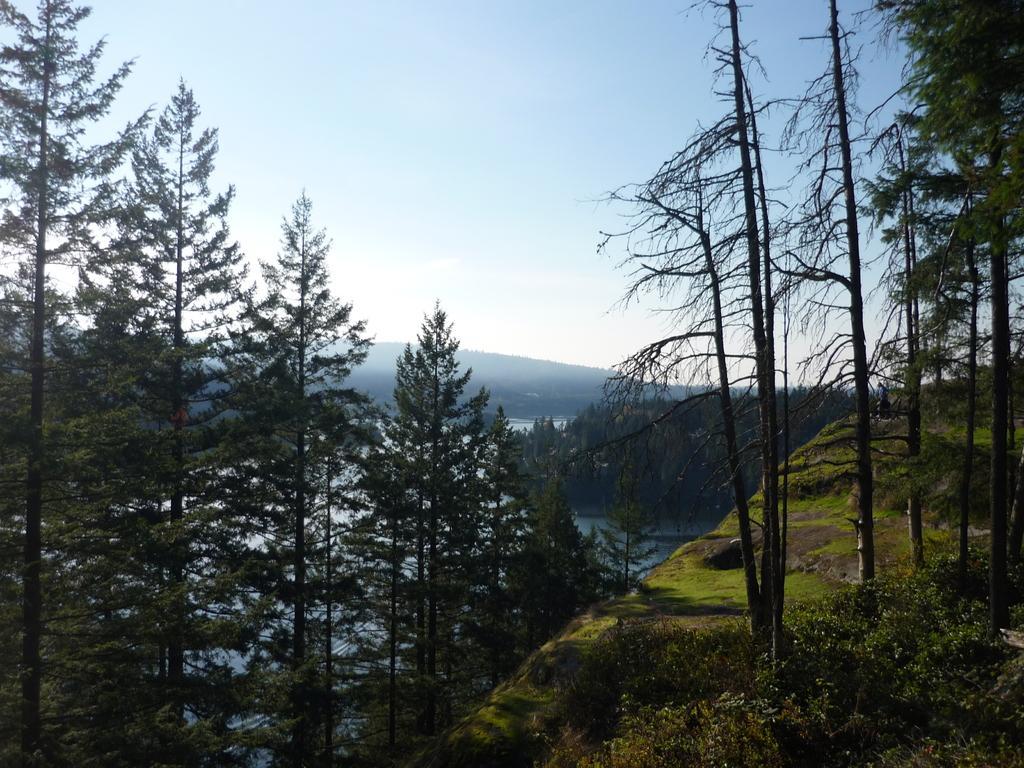Please provide a concise description of this image. In the picture I can see trees, the grass, the water, plants and some other objects. In the background I can see the sky. 